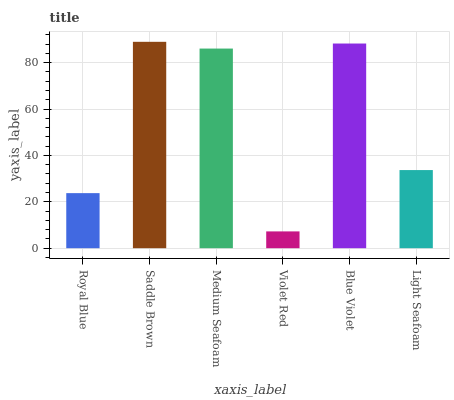Is Violet Red the minimum?
Answer yes or no. Yes. Is Saddle Brown the maximum?
Answer yes or no. Yes. Is Medium Seafoam the minimum?
Answer yes or no. No. Is Medium Seafoam the maximum?
Answer yes or no. No. Is Saddle Brown greater than Medium Seafoam?
Answer yes or no. Yes. Is Medium Seafoam less than Saddle Brown?
Answer yes or no. Yes. Is Medium Seafoam greater than Saddle Brown?
Answer yes or no. No. Is Saddle Brown less than Medium Seafoam?
Answer yes or no. No. Is Medium Seafoam the high median?
Answer yes or no. Yes. Is Light Seafoam the low median?
Answer yes or no. Yes. Is Saddle Brown the high median?
Answer yes or no. No. Is Blue Violet the low median?
Answer yes or no. No. 